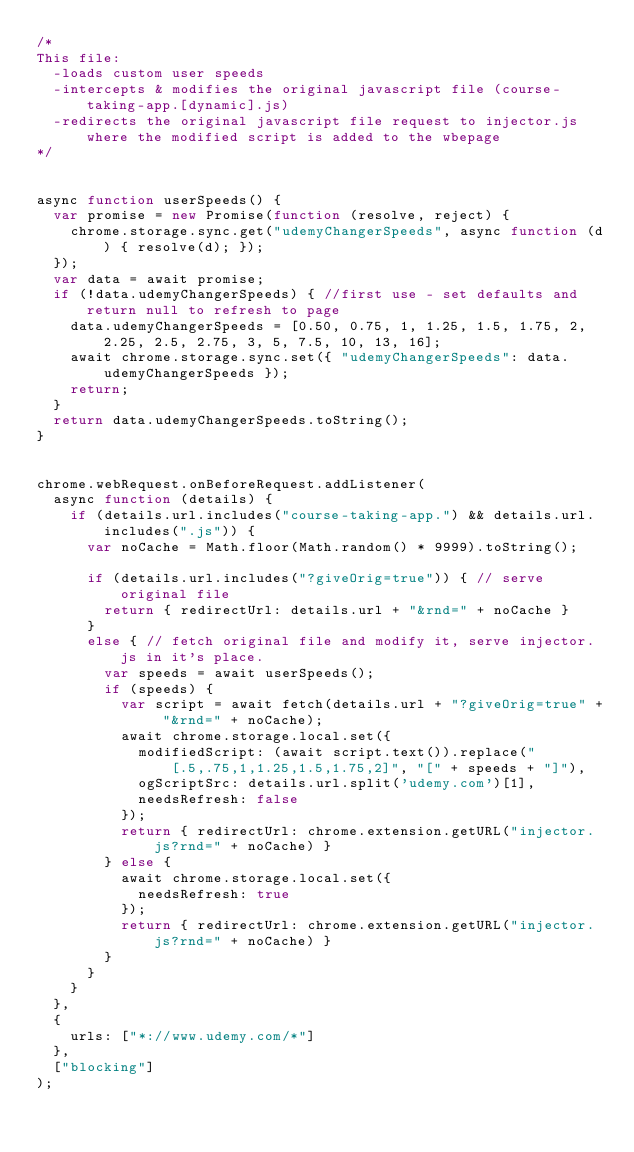<code> <loc_0><loc_0><loc_500><loc_500><_JavaScript_>/*
This file:
  -loads custom user speeds
  -intercepts & modifies the original javascript file (course-taking-app.[dynamic].js)
  -redirects the original javascript file request to injector.js where the modified script is added to the wbepage
*/


async function userSpeeds() {
  var promise = new Promise(function (resolve, reject) {
    chrome.storage.sync.get("udemyChangerSpeeds", async function (d) { resolve(d); });
  });
  var data = await promise;
  if (!data.udemyChangerSpeeds) { //first use - set defaults and return null to refresh to page
    data.udemyChangerSpeeds = [0.50, 0.75, 1, 1.25, 1.5, 1.75, 2, 2.25, 2.5, 2.75, 3, 5, 7.5, 10, 13, 16];
    await chrome.storage.sync.set({ "udemyChangerSpeeds": data.udemyChangerSpeeds });
    return;
  }
  return data.udemyChangerSpeeds.toString();
}


chrome.webRequest.onBeforeRequest.addListener(
  async function (details) {
    if (details.url.includes("course-taking-app.") && details.url.includes(".js")) {
      var noCache = Math.floor(Math.random() * 9999).toString();

      if (details.url.includes("?giveOrig=true")) { // serve original file
        return { redirectUrl: details.url + "&rnd=" + noCache }
      }
      else { // fetch original file and modify it, serve injector.js in it's place.
        var speeds = await userSpeeds();
        if (speeds) {
          var script = await fetch(details.url + "?giveOrig=true" + "&rnd=" + noCache);
          await chrome.storage.local.set({
            modifiedScript: (await script.text()).replace("[.5,.75,1,1.25,1.5,1.75,2]", "[" + speeds + "]"),
            ogScriptSrc: details.url.split('udemy.com')[1],
            needsRefresh: false
          });
          return { redirectUrl: chrome.extension.getURL("injector.js?rnd=" + noCache) }
        } else {
          await chrome.storage.local.set({
            needsRefresh: true
          });
          return { redirectUrl: chrome.extension.getURL("injector.js?rnd=" + noCache) }
        }
      }
    }
  },
  {
    urls: ["*://www.udemy.com/*"]
  },
  ["blocking"]
);

</code> 